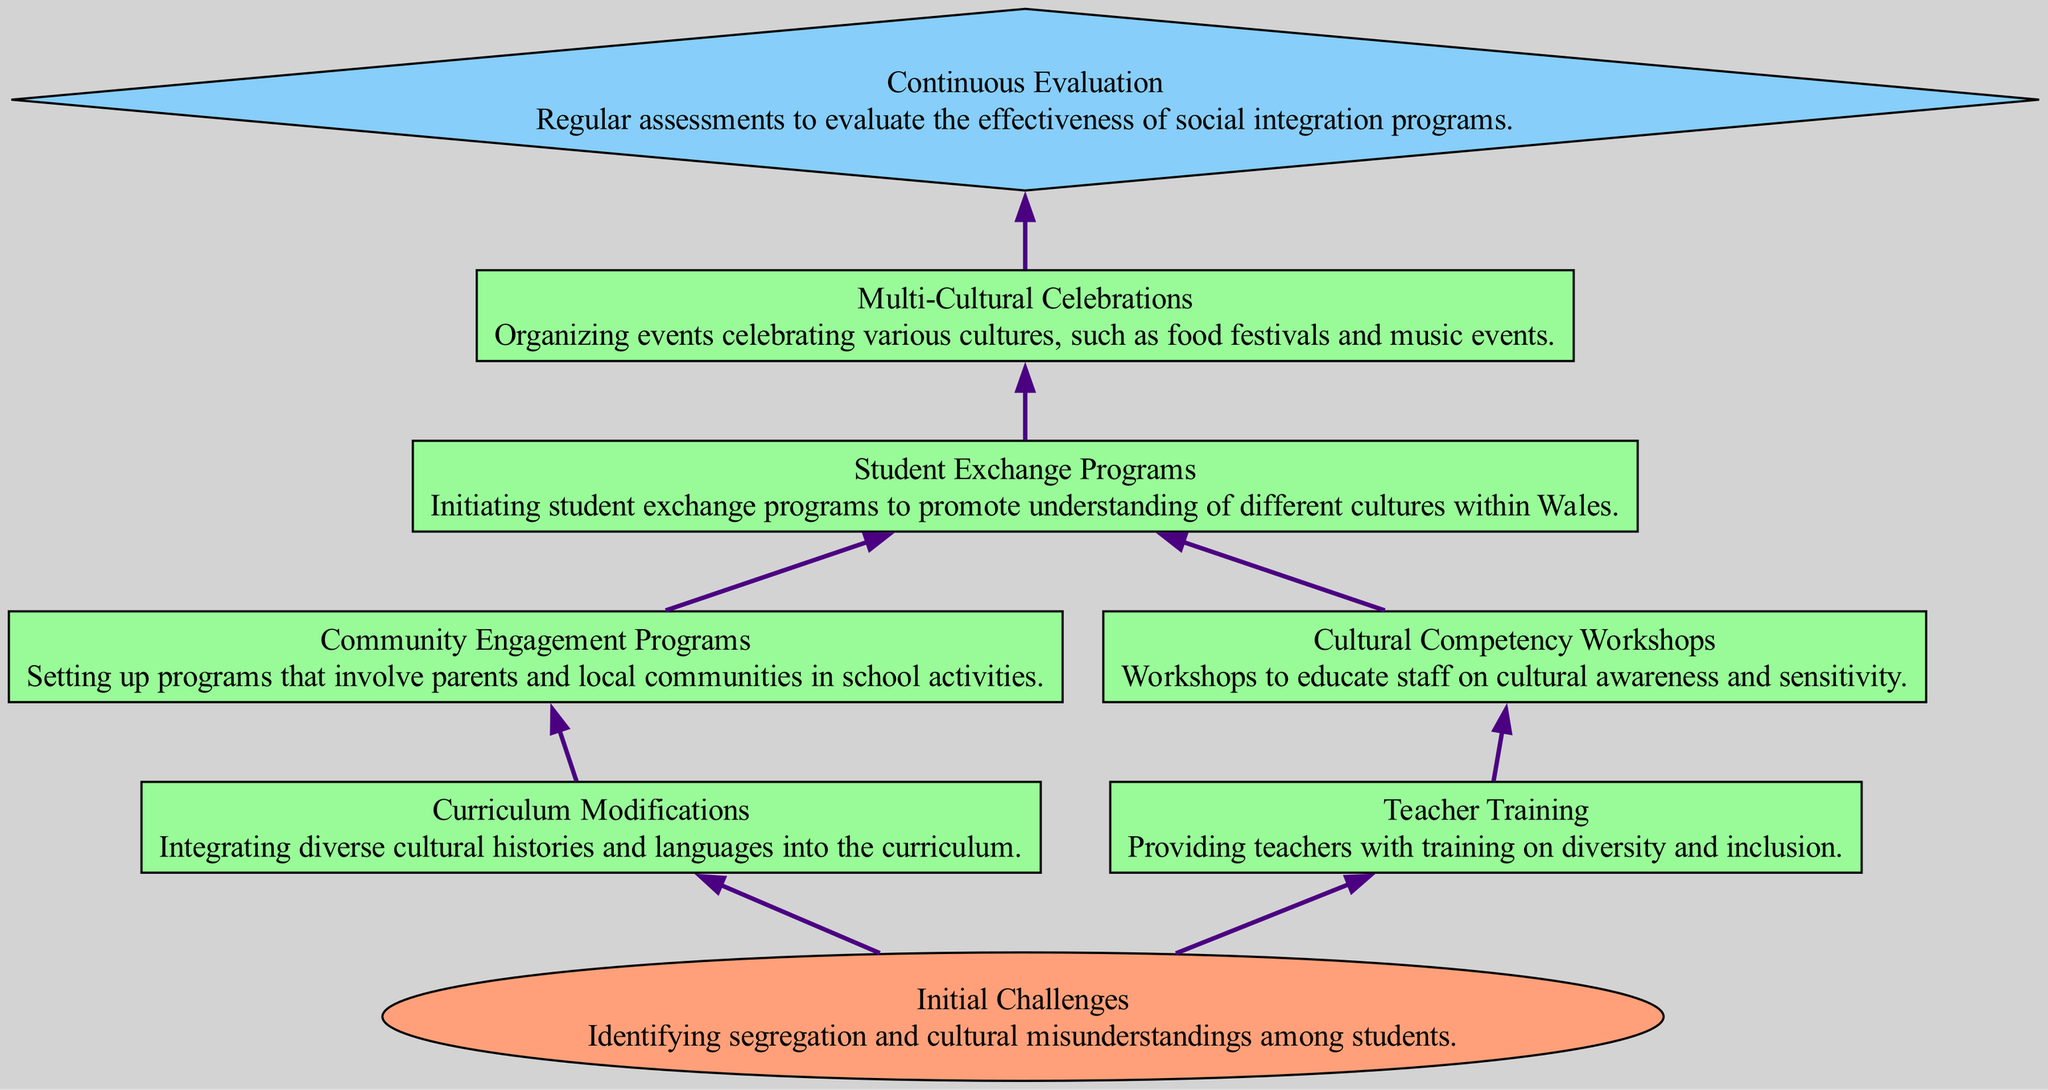What are the initial challenges identified in the diagram? The diagram indicates that the initial challenges include identifying segregation and cultural misunderstandings among students. This is found at the bottom of the flowchart and is the starting point for all subsequent strategies.
Answer: Identifying segregation and cultural misunderstandings among students How many process nodes are present in the flowchart? Counting the nodes representing processes, we find Curriculum Modifications, Teacher Training, Community Engagement Programs, Cultural Competency Workshops, Student Exchange Programs, and Multi-Cultural Celebrations. There are six process nodes in total.
Answer: Six What are the connections stemming from the Community Engagement Programs node? Examining the node for Community Engagement Programs, we see that it connects to Student Exchange Programs. This can be derived from reading the edges connecting these nodes in the flowchart.
Answer: Student Exchange Programs What type of node is Continuous Evaluation, and what does it represent? Continuous Evaluation is identified as an output type in the diagram. It signifies the regular assessments to evaluate the effectiveness of social integration programs, which is a crucial aspect of the process flow leading to final outcomes.
Answer: Output What is the last node in the flowchart? The last node in the flowchart is Continuous Evaluation, as it represents the end of the flow where outcomes are analyzed, confirming the final result of all previous social integration efforts.
Answer: Continuous Evaluation How does the Teacher Training node connect to the flow of social integration programs? The Teacher Training node connects to Cultural Competency Workshops, which is indicated by the edge linking these two nodes in the diagram. This shows that training directly influences the development of workshops aimed at improving teacher awareness regarding cultural diversity.
Answer: Cultural Competency Workshops 